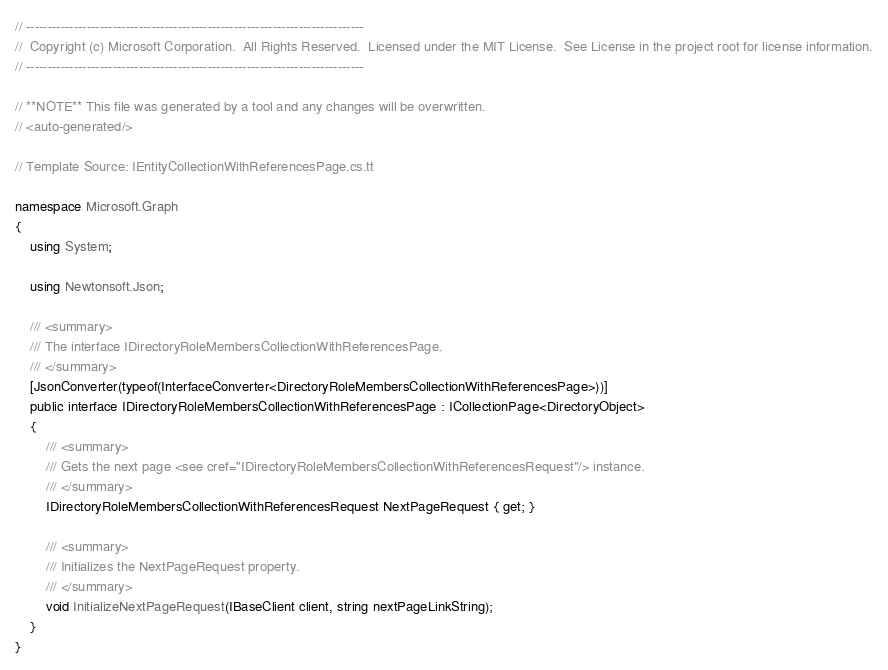Convert code to text. <code><loc_0><loc_0><loc_500><loc_500><_C#_>// ------------------------------------------------------------------------------
//  Copyright (c) Microsoft Corporation.  All Rights Reserved.  Licensed under the MIT License.  See License in the project root for license information.
// ------------------------------------------------------------------------------

// **NOTE** This file was generated by a tool and any changes will be overwritten.
// <auto-generated/>

// Template Source: IEntityCollectionWithReferencesPage.cs.tt

namespace Microsoft.Graph
{
    using System;

    using Newtonsoft.Json;

    /// <summary>
    /// The interface IDirectoryRoleMembersCollectionWithReferencesPage.
    /// </summary>
    [JsonConverter(typeof(InterfaceConverter<DirectoryRoleMembersCollectionWithReferencesPage>))]
    public interface IDirectoryRoleMembersCollectionWithReferencesPage : ICollectionPage<DirectoryObject>
    {
        /// <summary>
        /// Gets the next page <see cref="IDirectoryRoleMembersCollectionWithReferencesRequest"/> instance.
        /// </summary>
        IDirectoryRoleMembersCollectionWithReferencesRequest NextPageRequest { get; }

        /// <summary>
        /// Initializes the NextPageRequest property.
        /// </summary>
        void InitializeNextPageRequest(IBaseClient client, string nextPageLinkString);
    }
}
</code> 